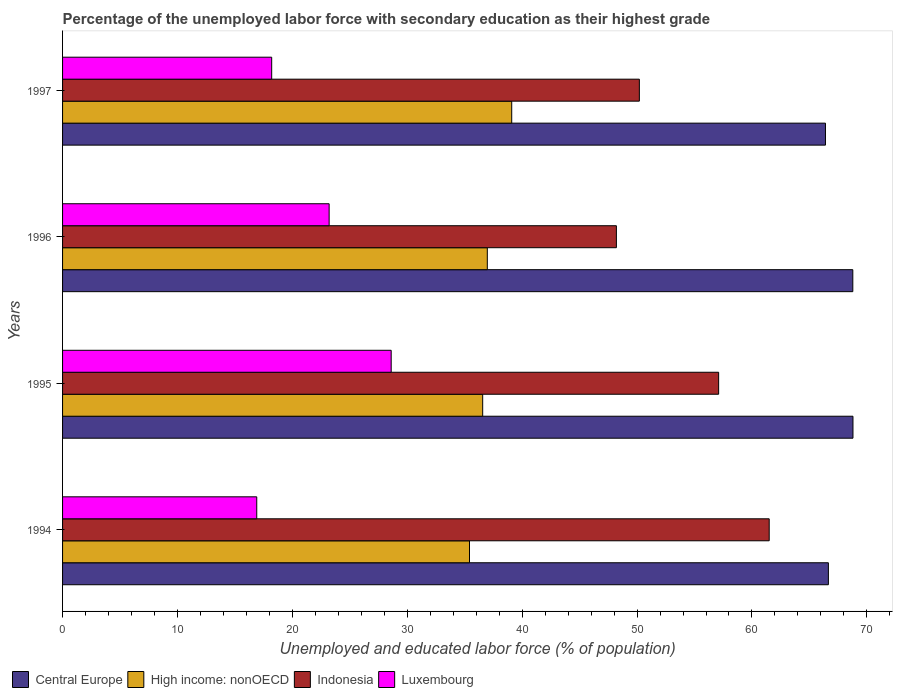Are the number of bars on each tick of the Y-axis equal?
Offer a terse response. Yes. What is the percentage of the unemployed labor force with secondary education in High income: nonOECD in 1995?
Offer a very short reply. 36.56. Across all years, what is the maximum percentage of the unemployed labor force with secondary education in High income: nonOECD?
Your answer should be compact. 39.09. Across all years, what is the minimum percentage of the unemployed labor force with secondary education in High income: nonOECD?
Keep it short and to the point. 35.42. In which year was the percentage of the unemployed labor force with secondary education in High income: nonOECD minimum?
Make the answer very short. 1994. What is the total percentage of the unemployed labor force with secondary education in Luxembourg in the graph?
Offer a terse response. 86.9. What is the difference between the percentage of the unemployed labor force with secondary education in Indonesia in 1994 and that in 1997?
Keep it short and to the point. 11.3. What is the difference between the percentage of the unemployed labor force with secondary education in Indonesia in 1994 and the percentage of the unemployed labor force with secondary education in Luxembourg in 1995?
Give a very brief answer. 32.9. What is the average percentage of the unemployed labor force with secondary education in Central Europe per year?
Make the answer very short. 67.65. In the year 1995, what is the difference between the percentage of the unemployed labor force with secondary education in Central Europe and percentage of the unemployed labor force with secondary education in Luxembourg?
Offer a very short reply. 40.19. In how many years, is the percentage of the unemployed labor force with secondary education in Indonesia greater than 38 %?
Your response must be concise. 4. What is the ratio of the percentage of the unemployed labor force with secondary education in Central Europe in 1995 to that in 1996?
Your answer should be very brief. 1. What is the difference between the highest and the second highest percentage of the unemployed labor force with secondary education in High income: nonOECD?
Provide a succinct answer. 2.12. What is the difference between the highest and the lowest percentage of the unemployed labor force with secondary education in Central Europe?
Provide a short and direct response. 2.39. In how many years, is the percentage of the unemployed labor force with secondary education in Indonesia greater than the average percentage of the unemployed labor force with secondary education in Indonesia taken over all years?
Keep it short and to the point. 2. What does the 4th bar from the top in 1996 represents?
Offer a very short reply. Central Europe. What does the 2nd bar from the bottom in 1996 represents?
Make the answer very short. High income: nonOECD. How many bars are there?
Provide a succinct answer. 16. How many years are there in the graph?
Your response must be concise. 4. Does the graph contain any zero values?
Your answer should be compact. No. How are the legend labels stacked?
Your answer should be very brief. Horizontal. What is the title of the graph?
Give a very brief answer. Percentage of the unemployed labor force with secondary education as their highest grade. Does "Europe(developing only)" appear as one of the legend labels in the graph?
Provide a short and direct response. No. What is the label or title of the X-axis?
Make the answer very short. Unemployed and educated labor force (% of population). What is the Unemployed and educated labor force (% of population) in Central Europe in 1994?
Give a very brief answer. 66.65. What is the Unemployed and educated labor force (% of population) in High income: nonOECD in 1994?
Your answer should be compact. 35.42. What is the Unemployed and educated labor force (% of population) in Indonesia in 1994?
Give a very brief answer. 61.5. What is the Unemployed and educated labor force (% of population) of Luxembourg in 1994?
Keep it short and to the point. 16.9. What is the Unemployed and educated labor force (% of population) of Central Europe in 1995?
Provide a short and direct response. 68.79. What is the Unemployed and educated labor force (% of population) in High income: nonOECD in 1995?
Provide a succinct answer. 36.56. What is the Unemployed and educated labor force (% of population) of Indonesia in 1995?
Your answer should be compact. 57.1. What is the Unemployed and educated labor force (% of population) in Luxembourg in 1995?
Ensure brevity in your answer.  28.6. What is the Unemployed and educated labor force (% of population) in Central Europe in 1996?
Keep it short and to the point. 68.78. What is the Unemployed and educated labor force (% of population) of High income: nonOECD in 1996?
Provide a short and direct response. 36.97. What is the Unemployed and educated labor force (% of population) of Indonesia in 1996?
Make the answer very short. 48.2. What is the Unemployed and educated labor force (% of population) of Luxembourg in 1996?
Your answer should be very brief. 23.2. What is the Unemployed and educated labor force (% of population) of Central Europe in 1997?
Keep it short and to the point. 66.4. What is the Unemployed and educated labor force (% of population) of High income: nonOECD in 1997?
Give a very brief answer. 39.09. What is the Unemployed and educated labor force (% of population) of Indonesia in 1997?
Your answer should be very brief. 50.2. What is the Unemployed and educated labor force (% of population) in Luxembourg in 1997?
Your answer should be very brief. 18.2. Across all years, what is the maximum Unemployed and educated labor force (% of population) of Central Europe?
Provide a succinct answer. 68.79. Across all years, what is the maximum Unemployed and educated labor force (% of population) of High income: nonOECD?
Offer a terse response. 39.09. Across all years, what is the maximum Unemployed and educated labor force (% of population) in Indonesia?
Give a very brief answer. 61.5. Across all years, what is the maximum Unemployed and educated labor force (% of population) in Luxembourg?
Provide a succinct answer. 28.6. Across all years, what is the minimum Unemployed and educated labor force (% of population) in Central Europe?
Keep it short and to the point. 66.4. Across all years, what is the minimum Unemployed and educated labor force (% of population) in High income: nonOECD?
Your answer should be very brief. 35.42. Across all years, what is the minimum Unemployed and educated labor force (% of population) in Indonesia?
Your answer should be compact. 48.2. Across all years, what is the minimum Unemployed and educated labor force (% of population) in Luxembourg?
Offer a terse response. 16.9. What is the total Unemployed and educated labor force (% of population) in Central Europe in the graph?
Make the answer very short. 270.61. What is the total Unemployed and educated labor force (% of population) in High income: nonOECD in the graph?
Provide a short and direct response. 148.04. What is the total Unemployed and educated labor force (% of population) in Indonesia in the graph?
Your response must be concise. 217. What is the total Unemployed and educated labor force (% of population) in Luxembourg in the graph?
Provide a succinct answer. 86.9. What is the difference between the Unemployed and educated labor force (% of population) of Central Europe in 1994 and that in 1995?
Offer a terse response. -2.14. What is the difference between the Unemployed and educated labor force (% of population) of High income: nonOECD in 1994 and that in 1995?
Provide a short and direct response. -1.15. What is the difference between the Unemployed and educated labor force (% of population) in Luxembourg in 1994 and that in 1995?
Your answer should be very brief. -11.7. What is the difference between the Unemployed and educated labor force (% of population) of Central Europe in 1994 and that in 1996?
Your answer should be compact. -2.13. What is the difference between the Unemployed and educated labor force (% of population) in High income: nonOECD in 1994 and that in 1996?
Provide a short and direct response. -1.55. What is the difference between the Unemployed and educated labor force (% of population) of Luxembourg in 1994 and that in 1996?
Make the answer very short. -6.3. What is the difference between the Unemployed and educated labor force (% of population) of Central Europe in 1994 and that in 1997?
Ensure brevity in your answer.  0.25. What is the difference between the Unemployed and educated labor force (% of population) in High income: nonOECD in 1994 and that in 1997?
Give a very brief answer. -3.67. What is the difference between the Unemployed and educated labor force (% of population) of Central Europe in 1995 and that in 1996?
Your answer should be very brief. 0.01. What is the difference between the Unemployed and educated labor force (% of population) of High income: nonOECD in 1995 and that in 1996?
Provide a succinct answer. -0.4. What is the difference between the Unemployed and educated labor force (% of population) in Indonesia in 1995 and that in 1996?
Provide a succinct answer. 8.9. What is the difference between the Unemployed and educated labor force (% of population) of Luxembourg in 1995 and that in 1996?
Make the answer very short. 5.4. What is the difference between the Unemployed and educated labor force (% of population) of Central Europe in 1995 and that in 1997?
Keep it short and to the point. 2.39. What is the difference between the Unemployed and educated labor force (% of population) in High income: nonOECD in 1995 and that in 1997?
Your response must be concise. -2.53. What is the difference between the Unemployed and educated labor force (% of population) of Indonesia in 1995 and that in 1997?
Give a very brief answer. 6.9. What is the difference between the Unemployed and educated labor force (% of population) in Luxembourg in 1995 and that in 1997?
Your response must be concise. 10.4. What is the difference between the Unemployed and educated labor force (% of population) in Central Europe in 1996 and that in 1997?
Provide a succinct answer. 2.38. What is the difference between the Unemployed and educated labor force (% of population) of High income: nonOECD in 1996 and that in 1997?
Your answer should be compact. -2.12. What is the difference between the Unemployed and educated labor force (% of population) of Luxembourg in 1996 and that in 1997?
Offer a very short reply. 5. What is the difference between the Unemployed and educated labor force (% of population) of Central Europe in 1994 and the Unemployed and educated labor force (% of population) of High income: nonOECD in 1995?
Your answer should be very brief. 30.09. What is the difference between the Unemployed and educated labor force (% of population) of Central Europe in 1994 and the Unemployed and educated labor force (% of population) of Indonesia in 1995?
Provide a short and direct response. 9.55. What is the difference between the Unemployed and educated labor force (% of population) of Central Europe in 1994 and the Unemployed and educated labor force (% of population) of Luxembourg in 1995?
Offer a terse response. 38.05. What is the difference between the Unemployed and educated labor force (% of population) of High income: nonOECD in 1994 and the Unemployed and educated labor force (% of population) of Indonesia in 1995?
Ensure brevity in your answer.  -21.68. What is the difference between the Unemployed and educated labor force (% of population) in High income: nonOECD in 1994 and the Unemployed and educated labor force (% of population) in Luxembourg in 1995?
Ensure brevity in your answer.  6.82. What is the difference between the Unemployed and educated labor force (% of population) of Indonesia in 1994 and the Unemployed and educated labor force (% of population) of Luxembourg in 1995?
Ensure brevity in your answer.  32.9. What is the difference between the Unemployed and educated labor force (% of population) of Central Europe in 1994 and the Unemployed and educated labor force (% of population) of High income: nonOECD in 1996?
Your response must be concise. 29.68. What is the difference between the Unemployed and educated labor force (% of population) of Central Europe in 1994 and the Unemployed and educated labor force (% of population) of Indonesia in 1996?
Your answer should be compact. 18.45. What is the difference between the Unemployed and educated labor force (% of population) of Central Europe in 1994 and the Unemployed and educated labor force (% of population) of Luxembourg in 1996?
Offer a very short reply. 43.45. What is the difference between the Unemployed and educated labor force (% of population) of High income: nonOECD in 1994 and the Unemployed and educated labor force (% of population) of Indonesia in 1996?
Give a very brief answer. -12.78. What is the difference between the Unemployed and educated labor force (% of population) of High income: nonOECD in 1994 and the Unemployed and educated labor force (% of population) of Luxembourg in 1996?
Provide a short and direct response. 12.22. What is the difference between the Unemployed and educated labor force (% of population) of Indonesia in 1994 and the Unemployed and educated labor force (% of population) of Luxembourg in 1996?
Your answer should be compact. 38.3. What is the difference between the Unemployed and educated labor force (% of population) in Central Europe in 1994 and the Unemployed and educated labor force (% of population) in High income: nonOECD in 1997?
Offer a very short reply. 27.56. What is the difference between the Unemployed and educated labor force (% of population) in Central Europe in 1994 and the Unemployed and educated labor force (% of population) in Indonesia in 1997?
Give a very brief answer. 16.45. What is the difference between the Unemployed and educated labor force (% of population) in Central Europe in 1994 and the Unemployed and educated labor force (% of population) in Luxembourg in 1997?
Provide a short and direct response. 48.45. What is the difference between the Unemployed and educated labor force (% of population) of High income: nonOECD in 1994 and the Unemployed and educated labor force (% of population) of Indonesia in 1997?
Offer a very short reply. -14.78. What is the difference between the Unemployed and educated labor force (% of population) of High income: nonOECD in 1994 and the Unemployed and educated labor force (% of population) of Luxembourg in 1997?
Your answer should be compact. 17.22. What is the difference between the Unemployed and educated labor force (% of population) in Indonesia in 1994 and the Unemployed and educated labor force (% of population) in Luxembourg in 1997?
Provide a succinct answer. 43.3. What is the difference between the Unemployed and educated labor force (% of population) in Central Europe in 1995 and the Unemployed and educated labor force (% of population) in High income: nonOECD in 1996?
Offer a terse response. 31.82. What is the difference between the Unemployed and educated labor force (% of population) of Central Europe in 1995 and the Unemployed and educated labor force (% of population) of Indonesia in 1996?
Your answer should be very brief. 20.59. What is the difference between the Unemployed and educated labor force (% of population) in Central Europe in 1995 and the Unemployed and educated labor force (% of population) in Luxembourg in 1996?
Your response must be concise. 45.59. What is the difference between the Unemployed and educated labor force (% of population) in High income: nonOECD in 1995 and the Unemployed and educated labor force (% of population) in Indonesia in 1996?
Offer a very short reply. -11.64. What is the difference between the Unemployed and educated labor force (% of population) of High income: nonOECD in 1995 and the Unemployed and educated labor force (% of population) of Luxembourg in 1996?
Keep it short and to the point. 13.36. What is the difference between the Unemployed and educated labor force (% of population) of Indonesia in 1995 and the Unemployed and educated labor force (% of population) of Luxembourg in 1996?
Make the answer very short. 33.9. What is the difference between the Unemployed and educated labor force (% of population) of Central Europe in 1995 and the Unemployed and educated labor force (% of population) of High income: nonOECD in 1997?
Your answer should be very brief. 29.7. What is the difference between the Unemployed and educated labor force (% of population) of Central Europe in 1995 and the Unemployed and educated labor force (% of population) of Indonesia in 1997?
Your response must be concise. 18.59. What is the difference between the Unemployed and educated labor force (% of population) in Central Europe in 1995 and the Unemployed and educated labor force (% of population) in Luxembourg in 1997?
Keep it short and to the point. 50.59. What is the difference between the Unemployed and educated labor force (% of population) in High income: nonOECD in 1995 and the Unemployed and educated labor force (% of population) in Indonesia in 1997?
Give a very brief answer. -13.64. What is the difference between the Unemployed and educated labor force (% of population) of High income: nonOECD in 1995 and the Unemployed and educated labor force (% of population) of Luxembourg in 1997?
Provide a succinct answer. 18.36. What is the difference between the Unemployed and educated labor force (% of population) in Indonesia in 1995 and the Unemployed and educated labor force (% of population) in Luxembourg in 1997?
Keep it short and to the point. 38.9. What is the difference between the Unemployed and educated labor force (% of population) of Central Europe in 1996 and the Unemployed and educated labor force (% of population) of High income: nonOECD in 1997?
Your response must be concise. 29.69. What is the difference between the Unemployed and educated labor force (% of population) of Central Europe in 1996 and the Unemployed and educated labor force (% of population) of Indonesia in 1997?
Offer a terse response. 18.58. What is the difference between the Unemployed and educated labor force (% of population) of Central Europe in 1996 and the Unemployed and educated labor force (% of population) of Luxembourg in 1997?
Provide a succinct answer. 50.58. What is the difference between the Unemployed and educated labor force (% of population) of High income: nonOECD in 1996 and the Unemployed and educated labor force (% of population) of Indonesia in 1997?
Provide a succinct answer. -13.23. What is the difference between the Unemployed and educated labor force (% of population) in High income: nonOECD in 1996 and the Unemployed and educated labor force (% of population) in Luxembourg in 1997?
Provide a succinct answer. 18.77. What is the average Unemployed and educated labor force (% of population) in Central Europe per year?
Keep it short and to the point. 67.65. What is the average Unemployed and educated labor force (% of population) of High income: nonOECD per year?
Your response must be concise. 37.01. What is the average Unemployed and educated labor force (% of population) in Indonesia per year?
Make the answer very short. 54.25. What is the average Unemployed and educated labor force (% of population) in Luxembourg per year?
Your response must be concise. 21.73. In the year 1994, what is the difference between the Unemployed and educated labor force (% of population) of Central Europe and Unemployed and educated labor force (% of population) of High income: nonOECD?
Your response must be concise. 31.23. In the year 1994, what is the difference between the Unemployed and educated labor force (% of population) of Central Europe and Unemployed and educated labor force (% of population) of Indonesia?
Make the answer very short. 5.15. In the year 1994, what is the difference between the Unemployed and educated labor force (% of population) of Central Europe and Unemployed and educated labor force (% of population) of Luxembourg?
Your answer should be compact. 49.75. In the year 1994, what is the difference between the Unemployed and educated labor force (% of population) of High income: nonOECD and Unemployed and educated labor force (% of population) of Indonesia?
Keep it short and to the point. -26.08. In the year 1994, what is the difference between the Unemployed and educated labor force (% of population) in High income: nonOECD and Unemployed and educated labor force (% of population) in Luxembourg?
Your response must be concise. 18.52. In the year 1994, what is the difference between the Unemployed and educated labor force (% of population) in Indonesia and Unemployed and educated labor force (% of population) in Luxembourg?
Give a very brief answer. 44.6. In the year 1995, what is the difference between the Unemployed and educated labor force (% of population) of Central Europe and Unemployed and educated labor force (% of population) of High income: nonOECD?
Your answer should be very brief. 32.23. In the year 1995, what is the difference between the Unemployed and educated labor force (% of population) of Central Europe and Unemployed and educated labor force (% of population) of Indonesia?
Your answer should be compact. 11.69. In the year 1995, what is the difference between the Unemployed and educated labor force (% of population) in Central Europe and Unemployed and educated labor force (% of population) in Luxembourg?
Provide a short and direct response. 40.19. In the year 1995, what is the difference between the Unemployed and educated labor force (% of population) of High income: nonOECD and Unemployed and educated labor force (% of population) of Indonesia?
Provide a succinct answer. -20.54. In the year 1995, what is the difference between the Unemployed and educated labor force (% of population) in High income: nonOECD and Unemployed and educated labor force (% of population) in Luxembourg?
Provide a succinct answer. 7.96. In the year 1996, what is the difference between the Unemployed and educated labor force (% of population) of Central Europe and Unemployed and educated labor force (% of population) of High income: nonOECD?
Keep it short and to the point. 31.81. In the year 1996, what is the difference between the Unemployed and educated labor force (% of population) of Central Europe and Unemployed and educated labor force (% of population) of Indonesia?
Ensure brevity in your answer.  20.58. In the year 1996, what is the difference between the Unemployed and educated labor force (% of population) in Central Europe and Unemployed and educated labor force (% of population) in Luxembourg?
Give a very brief answer. 45.58. In the year 1996, what is the difference between the Unemployed and educated labor force (% of population) of High income: nonOECD and Unemployed and educated labor force (% of population) of Indonesia?
Offer a very short reply. -11.23. In the year 1996, what is the difference between the Unemployed and educated labor force (% of population) of High income: nonOECD and Unemployed and educated labor force (% of population) of Luxembourg?
Provide a short and direct response. 13.77. In the year 1996, what is the difference between the Unemployed and educated labor force (% of population) in Indonesia and Unemployed and educated labor force (% of population) in Luxembourg?
Offer a very short reply. 25. In the year 1997, what is the difference between the Unemployed and educated labor force (% of population) of Central Europe and Unemployed and educated labor force (% of population) of High income: nonOECD?
Provide a short and direct response. 27.31. In the year 1997, what is the difference between the Unemployed and educated labor force (% of population) of Central Europe and Unemployed and educated labor force (% of population) of Indonesia?
Ensure brevity in your answer.  16.2. In the year 1997, what is the difference between the Unemployed and educated labor force (% of population) in Central Europe and Unemployed and educated labor force (% of population) in Luxembourg?
Provide a succinct answer. 48.2. In the year 1997, what is the difference between the Unemployed and educated labor force (% of population) in High income: nonOECD and Unemployed and educated labor force (% of population) in Indonesia?
Your answer should be very brief. -11.11. In the year 1997, what is the difference between the Unemployed and educated labor force (% of population) of High income: nonOECD and Unemployed and educated labor force (% of population) of Luxembourg?
Keep it short and to the point. 20.89. In the year 1997, what is the difference between the Unemployed and educated labor force (% of population) in Indonesia and Unemployed and educated labor force (% of population) in Luxembourg?
Give a very brief answer. 32. What is the ratio of the Unemployed and educated labor force (% of population) in Central Europe in 1994 to that in 1995?
Offer a very short reply. 0.97. What is the ratio of the Unemployed and educated labor force (% of population) of High income: nonOECD in 1994 to that in 1995?
Offer a terse response. 0.97. What is the ratio of the Unemployed and educated labor force (% of population) in Indonesia in 1994 to that in 1995?
Your answer should be compact. 1.08. What is the ratio of the Unemployed and educated labor force (% of population) of Luxembourg in 1994 to that in 1995?
Your answer should be very brief. 0.59. What is the ratio of the Unemployed and educated labor force (% of population) of Central Europe in 1994 to that in 1996?
Ensure brevity in your answer.  0.97. What is the ratio of the Unemployed and educated labor force (% of population) in High income: nonOECD in 1994 to that in 1996?
Give a very brief answer. 0.96. What is the ratio of the Unemployed and educated labor force (% of population) in Indonesia in 1994 to that in 1996?
Offer a very short reply. 1.28. What is the ratio of the Unemployed and educated labor force (% of population) in Luxembourg in 1994 to that in 1996?
Provide a short and direct response. 0.73. What is the ratio of the Unemployed and educated labor force (% of population) in High income: nonOECD in 1994 to that in 1997?
Your answer should be very brief. 0.91. What is the ratio of the Unemployed and educated labor force (% of population) of Indonesia in 1994 to that in 1997?
Give a very brief answer. 1.23. What is the ratio of the Unemployed and educated labor force (% of population) in Indonesia in 1995 to that in 1996?
Your answer should be compact. 1.18. What is the ratio of the Unemployed and educated labor force (% of population) of Luxembourg in 1995 to that in 1996?
Your answer should be very brief. 1.23. What is the ratio of the Unemployed and educated labor force (% of population) in Central Europe in 1995 to that in 1997?
Offer a very short reply. 1.04. What is the ratio of the Unemployed and educated labor force (% of population) of High income: nonOECD in 1995 to that in 1997?
Provide a short and direct response. 0.94. What is the ratio of the Unemployed and educated labor force (% of population) in Indonesia in 1995 to that in 1997?
Keep it short and to the point. 1.14. What is the ratio of the Unemployed and educated labor force (% of population) in Luxembourg in 1995 to that in 1997?
Ensure brevity in your answer.  1.57. What is the ratio of the Unemployed and educated labor force (% of population) in Central Europe in 1996 to that in 1997?
Your answer should be very brief. 1.04. What is the ratio of the Unemployed and educated labor force (% of population) in High income: nonOECD in 1996 to that in 1997?
Offer a very short reply. 0.95. What is the ratio of the Unemployed and educated labor force (% of population) of Indonesia in 1996 to that in 1997?
Your answer should be compact. 0.96. What is the ratio of the Unemployed and educated labor force (% of population) of Luxembourg in 1996 to that in 1997?
Your answer should be compact. 1.27. What is the difference between the highest and the second highest Unemployed and educated labor force (% of population) of Central Europe?
Offer a very short reply. 0.01. What is the difference between the highest and the second highest Unemployed and educated labor force (% of population) in High income: nonOECD?
Offer a terse response. 2.12. What is the difference between the highest and the second highest Unemployed and educated labor force (% of population) of Indonesia?
Make the answer very short. 4.4. What is the difference between the highest and the second highest Unemployed and educated labor force (% of population) of Luxembourg?
Make the answer very short. 5.4. What is the difference between the highest and the lowest Unemployed and educated labor force (% of population) of Central Europe?
Provide a short and direct response. 2.39. What is the difference between the highest and the lowest Unemployed and educated labor force (% of population) of High income: nonOECD?
Provide a short and direct response. 3.67. What is the difference between the highest and the lowest Unemployed and educated labor force (% of population) of Indonesia?
Offer a very short reply. 13.3. What is the difference between the highest and the lowest Unemployed and educated labor force (% of population) of Luxembourg?
Offer a very short reply. 11.7. 